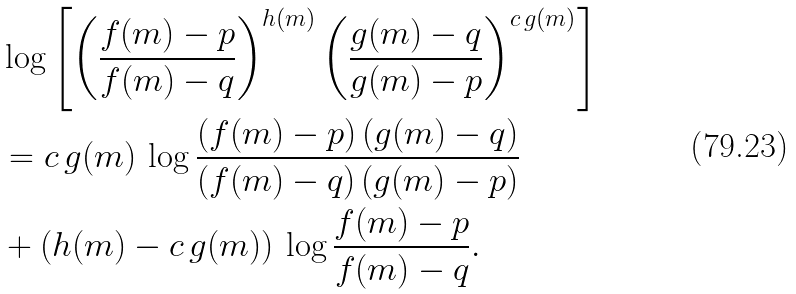<formula> <loc_0><loc_0><loc_500><loc_500>& \log \left [ \left ( \frac { f ( m ) - p } { f ( m ) - q } \right ) ^ { h ( m ) } \left ( \frac { g ( m ) - q } { g ( m ) - p } \right ) ^ { c \, g ( m ) } \right ] \\ & = c \, g ( m ) \, \log \frac { ( f ( m ) - p ) \, ( g ( m ) - q ) } { ( f ( m ) - q ) \, ( g ( m ) - p ) } \\ & + ( h ( m ) - c \, g ( m ) ) \, \log \frac { f ( m ) - p } { f ( m ) - q } .</formula> 